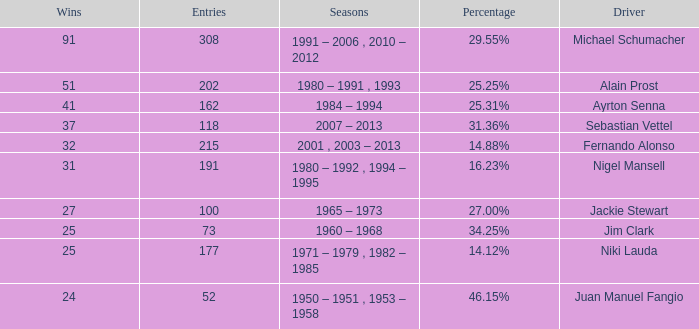Which driver has less than 37 wins and at 14.12%? 177.0. 